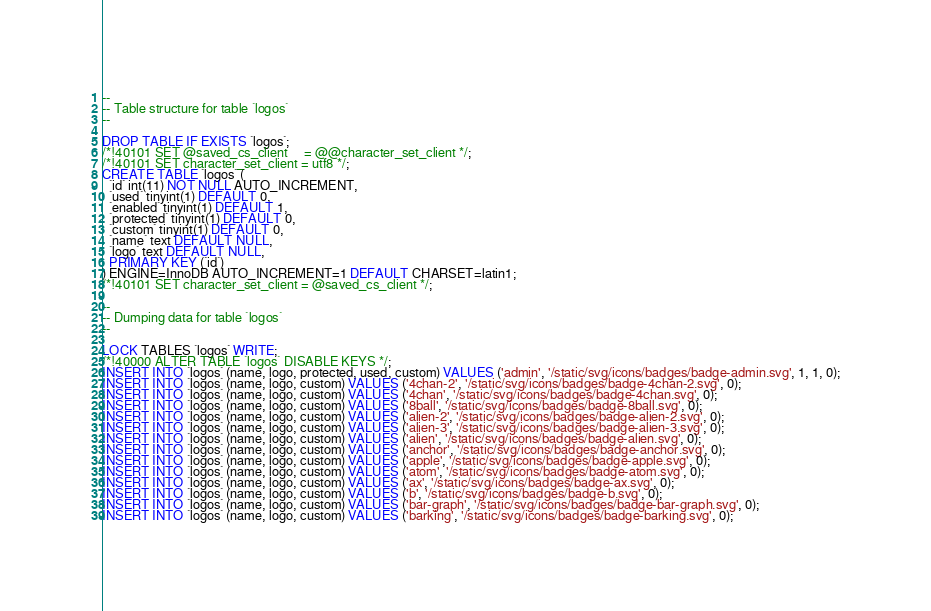Convert code to text. <code><loc_0><loc_0><loc_500><loc_500><_SQL_>--
-- Table structure for table `logos`
--

DROP TABLE IF EXISTS `logos`;
/*!40101 SET @saved_cs_client     = @@character_set_client */;
/*!40101 SET character_set_client = utf8 */;
CREATE TABLE `logos` (
  `id` int(11) NOT NULL AUTO_INCREMENT,
  `used` tinyint(1) DEFAULT 0,
  `enabled` tinyint(1) DEFAULT 1,
  `protected` tinyint(1) DEFAULT 0,
  `custom` tinyint(1) DEFAULT 0,
  `name` text DEFAULT NULL,
  `logo` text DEFAULT NULL,
  PRIMARY KEY (`id`)
) ENGINE=InnoDB AUTO_INCREMENT=1 DEFAULT CHARSET=latin1;
/*!40101 SET character_set_client = @saved_cs_client */;

--
-- Dumping data for table `logos`
--

LOCK TABLES `logos` WRITE;
/*!40000 ALTER TABLE `logos` DISABLE KEYS */;
INSERT INTO `logos` (name, logo, protected, used, custom) VALUES ('admin', '/static/svg/icons/badges/badge-admin.svg', 1, 1, 0);
INSERT INTO `logos` (name, logo, custom) VALUES ('4chan-2', '/static/svg/icons/badges/badge-4chan-2.svg', 0);
INSERT INTO `logos` (name, logo, custom) VALUES ('4chan', '/static/svg/icons/badges/badge-4chan.svg', 0);
INSERT INTO `logos` (name, logo, custom) VALUES ('8ball', '/static/svg/icons/badges/badge-8ball.svg', 0);
INSERT INTO `logos` (name, logo, custom) VALUES ('alien-2', '/static/svg/icons/badges/badge-alien-2.svg', 0);
INSERT INTO `logos` (name, logo, custom) VALUES ('alien-3', '/static/svg/icons/badges/badge-alien-3.svg', 0);
INSERT INTO `logos` (name, logo, custom) VALUES ('alien', '/static/svg/icons/badges/badge-alien.svg', 0);
INSERT INTO `logos` (name, logo, custom) VALUES ('anchor', '/static/svg/icons/badges/badge-anchor.svg', 0);
INSERT INTO `logos` (name, logo, custom) VALUES ('apple', '/static/svg/icons/badges/badge-apple.svg', 0);
INSERT INTO `logos` (name, logo, custom) VALUES ('atom', '/static/svg/icons/badges/badge-atom.svg', 0);
INSERT INTO `logos` (name, logo, custom) VALUES ('ax', '/static/svg/icons/badges/badge-ax.svg', 0);
INSERT INTO `logos` (name, logo, custom) VALUES ('b', '/static/svg/icons/badges/badge-b.svg', 0);
INSERT INTO `logos` (name, logo, custom) VALUES ('bar-graph', '/static/svg/icons/badges/badge-bar-graph.svg', 0);
INSERT INTO `logos` (name, logo, custom) VALUES ('barking', '/static/svg/icons/badges/badge-barking.svg', 0);</code> 